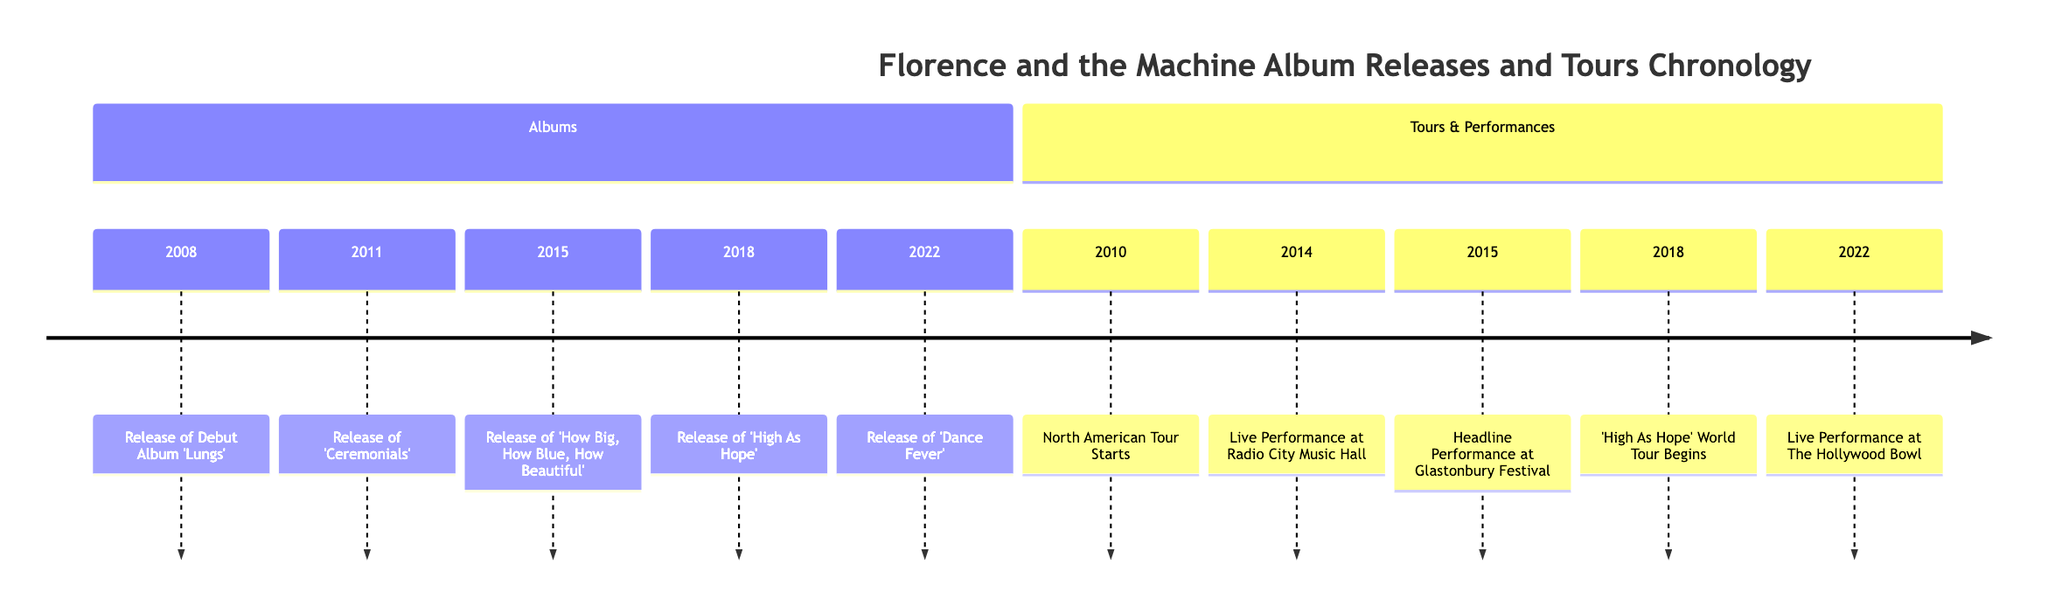What year did Florence and the Machine release their debut album 'Lungs'? The diagram indicates that 'Lungs' was released in 2008. This can be located in the Albums section of the timeline.
Answer: 2008 What is the significant event that occurred on October 19, 2010? Looking at the timeline, October 19, 2010, is marked by the start of the North American tour. This is mentioned under the Tours & Performances section.
Answer: North American Tour Starts How many albums did Florence and the Machine release by 2022? By reviewing the Albums section of the timeline, it shows five distinct album releases from 'Lungs' in 2008 to 'Dance Fever' in 2022. Therefore, the count of albums is five.
Answer: 5 Which album includes the song 'Shake It Out'? Referencing the Albums section, 'Shake It Out' is featured on the album 'Ceremonials', which was released in 2011.
Answer: Ceremonials What was the location of the live performance on December 12, 2014? December 12, 2014, marks a significant live performance at Radio City Music Hall, as stated in the Tours & Performances section. The location is explicitly mentioned here.
Answer: Radio City Music Hall Which tour began on September 8, 2018? According to the timeline, the 'High As Hope' world tour began on September 8, 2018, as detailed in the Tours & Performances section.
Answer: 'High As Hope' World Tour Begins What important milestone occurred in 2015 related to Glastonbury Festival? The timeline indicates that in 2015 Florence and the Machine headlined the Glastonbury Festival, which is mentioned as a major performance in the Tours & Performances section.
Answer: Headline Performance at Glastonbury Festival How many years passed between the release of 'Lungs' and 'Dance Fever'? The release year of 'Lungs' is 2008 and 'Dance Fever' is 2022. To find the difference, we subtract 2008 from 2022, resulting in 14 years.
Answer: 14 years Which album was released immediately before 'High As Hope'? The timeline shows that 'How Big, How Blue, How Beautiful' was released in 2015, which is the album released immediately before 'High As Hope' in 2018.
Answer: How Big, How Blue, How Beautiful 